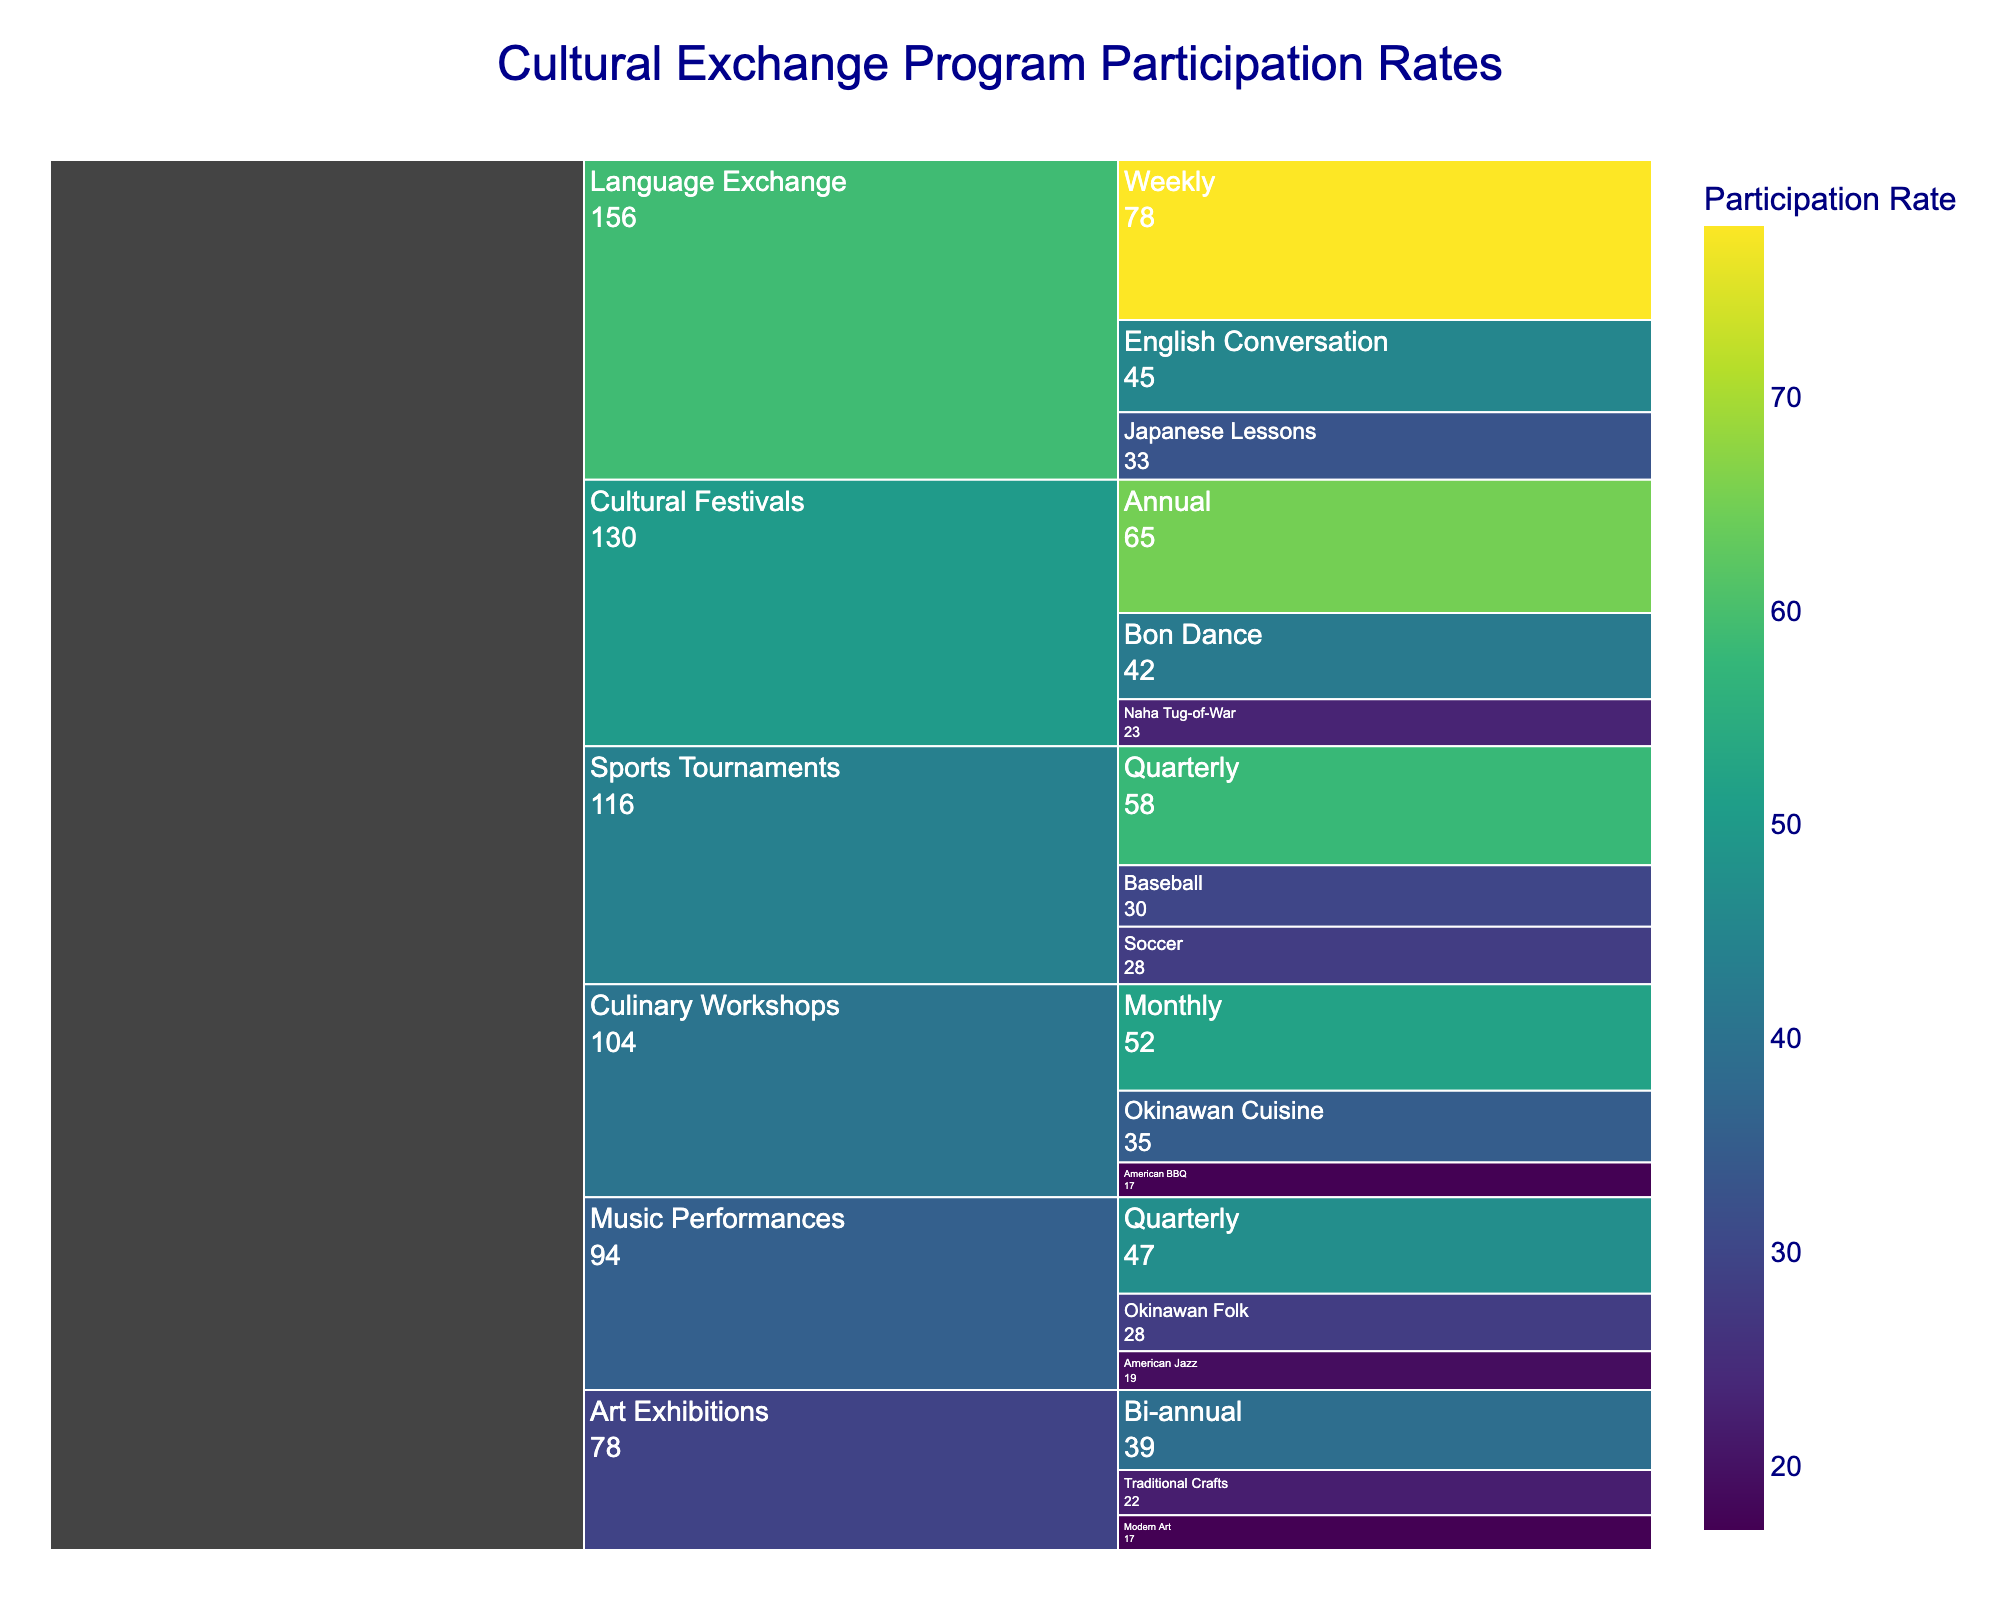What's the title of the chart? The title can be found at the top of the figure. It helps provide context for the entire chart.
Answer: Cultural Exchange Program Participation Rates Which event type has the highest participation rate? Look at the colors and values in the chart. The event type with the highest value or the darkest color corresponds to the highest participation rate.
Answer: Language Exchange What is the participation rate for Bon Dance festivals? Find the "Bon Dance" label under "Cultural Festivals" and note the shown value.
Answer: 42 What is the total participation rate for Quarterly sports tournaments? Add the participation rates for Baseball and Soccer under "Quarterly" in "Sports Tournaments". (30 + 28)
Answer: 58 Which type of Language Exchange has the highest participation rate? Look at the subcategories under "Language Exchange" and compare their values.
Answer: Weekly Compare the participation rates of Okinawan Folk music performances and American Jazz performances. Which is higher? Find the values for "Okinawan Folk" and "American Jazz" under "Music Performances" and compare.
Answer: Okinawan Folk What is the average participation rate for Art Exhibitions? Add the participation rates for Traditional Crafts and Modern Art, then divide by the number of types. (22 + 17) / 2
Answer: 19.5 What is the least popular cultural festival event? Look at the values under "Cultural Festivals" and find the lowest number.
Answer: Naha Tug-of-War How frequently are Culinary Workshops held when considering the most common frequency? Check the frequencies listed under "Culinary Workshops" and find which one has the highest participation rate.
Answer: Monthly 